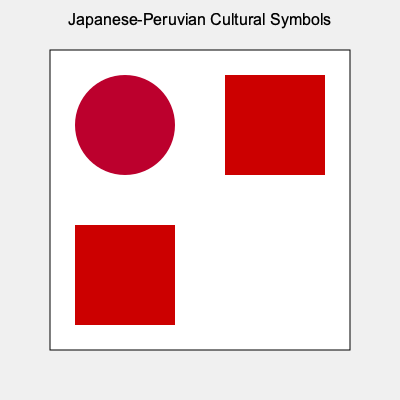In the given arrangement of Japanese and Peruvian cultural symbols, what is the ratio of the area occupied by red elements to the total area of the square grid? To solve this problem, we need to follow these steps:

1. Identify the red elements:
   - The circle (Japanese flag symbol)
   - Two red squares (from the Peruvian flag)

2. Calculate the total area of the square grid:
   - Side length of the grid = 300 units
   - Total area = $300 \times 300 = 90,000$ square units

3. Calculate the area of the circle:
   - Radius of the circle = 50 units
   - Area of the circle = $\pi r^2 = \pi \times 50^2 = 7,853.98$ square units

4. Calculate the area of the two red squares:
   - Side length of each square = 100 units
   - Area of one square = $100 \times 100 = 10,000$ square units
   - Area of two squares = $2 \times 10,000 = 20,000$ square units

5. Calculate the total red area:
   - Total red area = Area of circle + Area of two red squares
   - Total red area = $7,853.98 + 20,000 = 27,853.98$ square units

6. Calculate the ratio:
   - Ratio = Red area / Total area
   - Ratio = $27,853.98 / 90,000 = 0.3095$

7. Simplify the ratio:
   - Approximately $31/100$ or $0.31$ or $31\%$
Answer: 31:100 